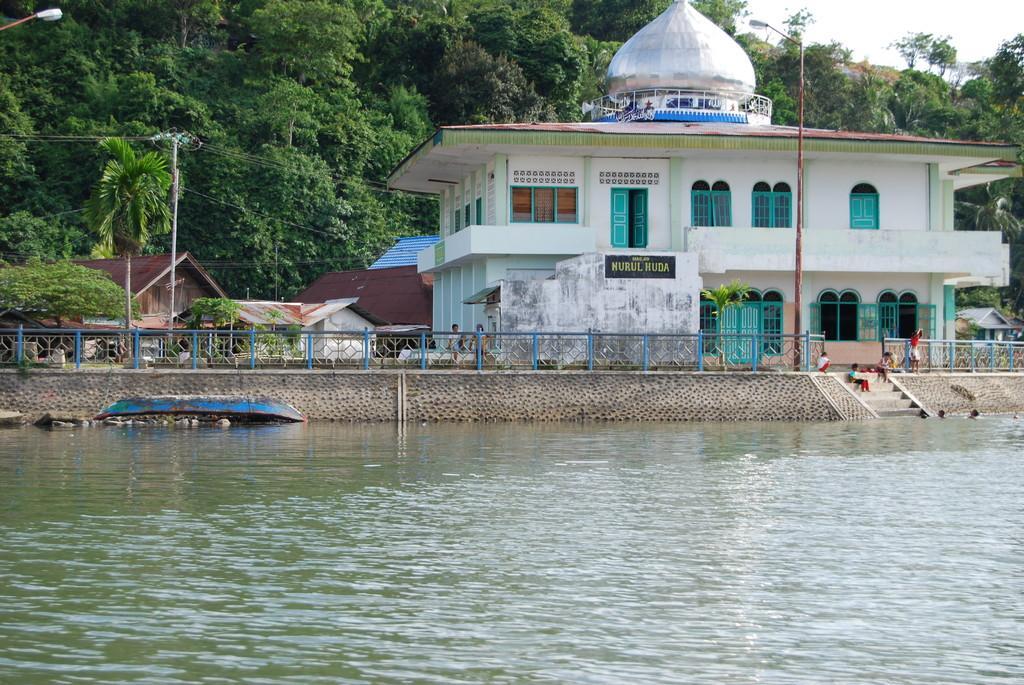Describe this image in one or two sentences. As we can see in the image there is water, fence, few people, street lamp, current pole, buildings trees and at the top there is sky. 